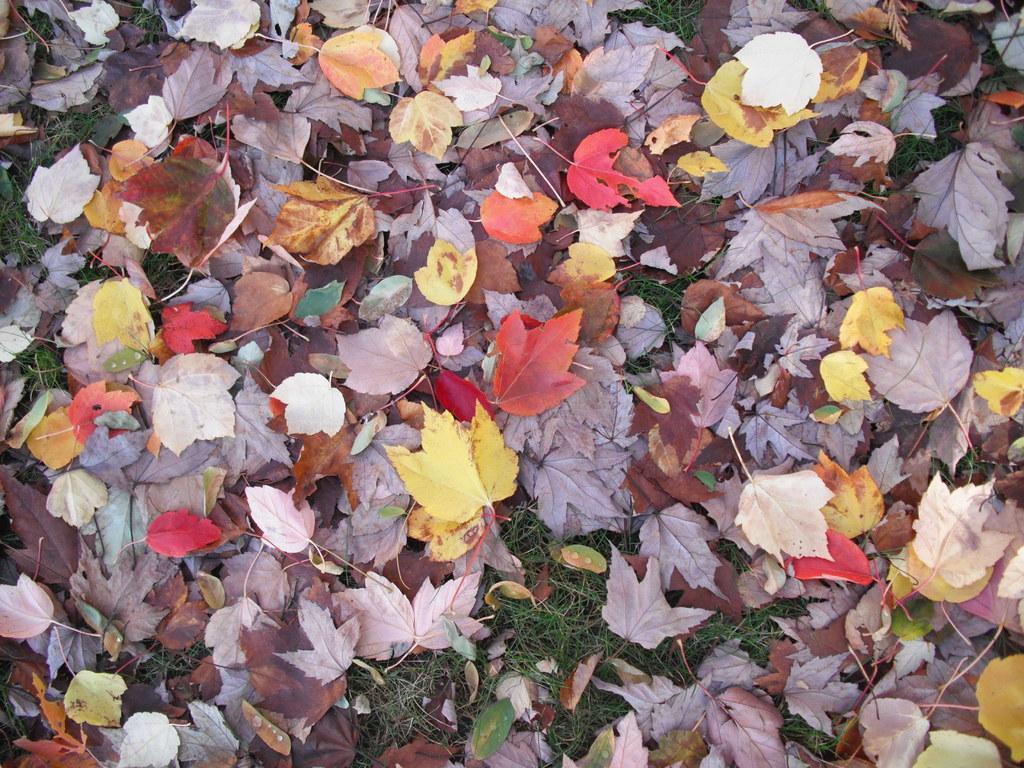How would you summarize this image in a sentence or two? In this image, we can see some leaves on the grass. 